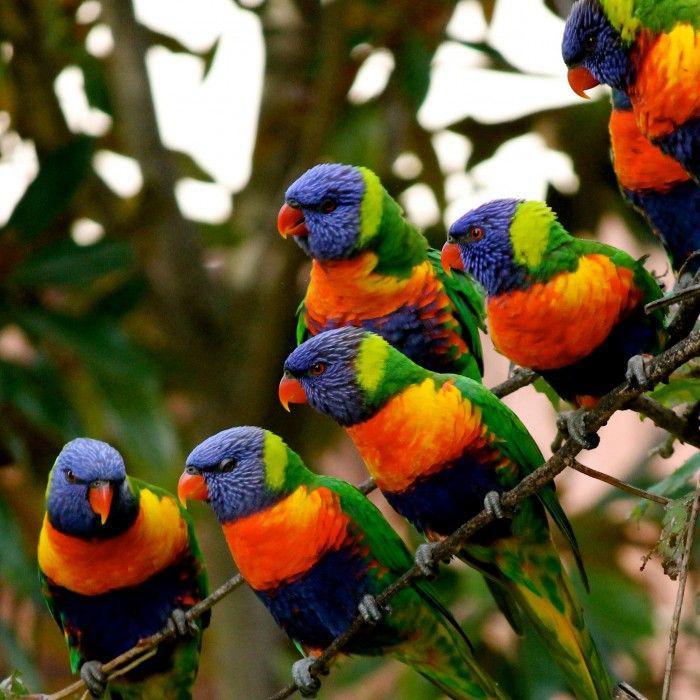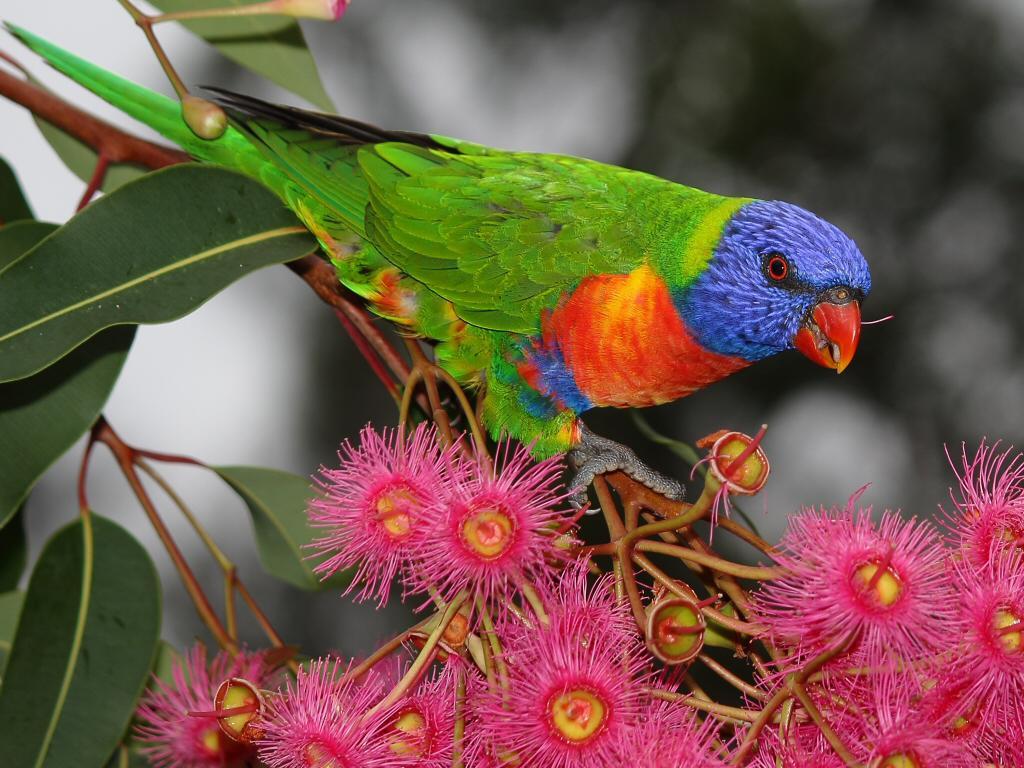The first image is the image on the left, the second image is the image on the right. Evaluate the accuracy of this statement regarding the images: "An image shows a person with more than one parrot atop her head.". Is it true? Answer yes or no. No. The first image is the image on the left, the second image is the image on the right. Considering the images on both sides, is "One smiling woman who is not wearing a hat has exactly one green bird perched on her head." valid? Answer yes or no. No. 